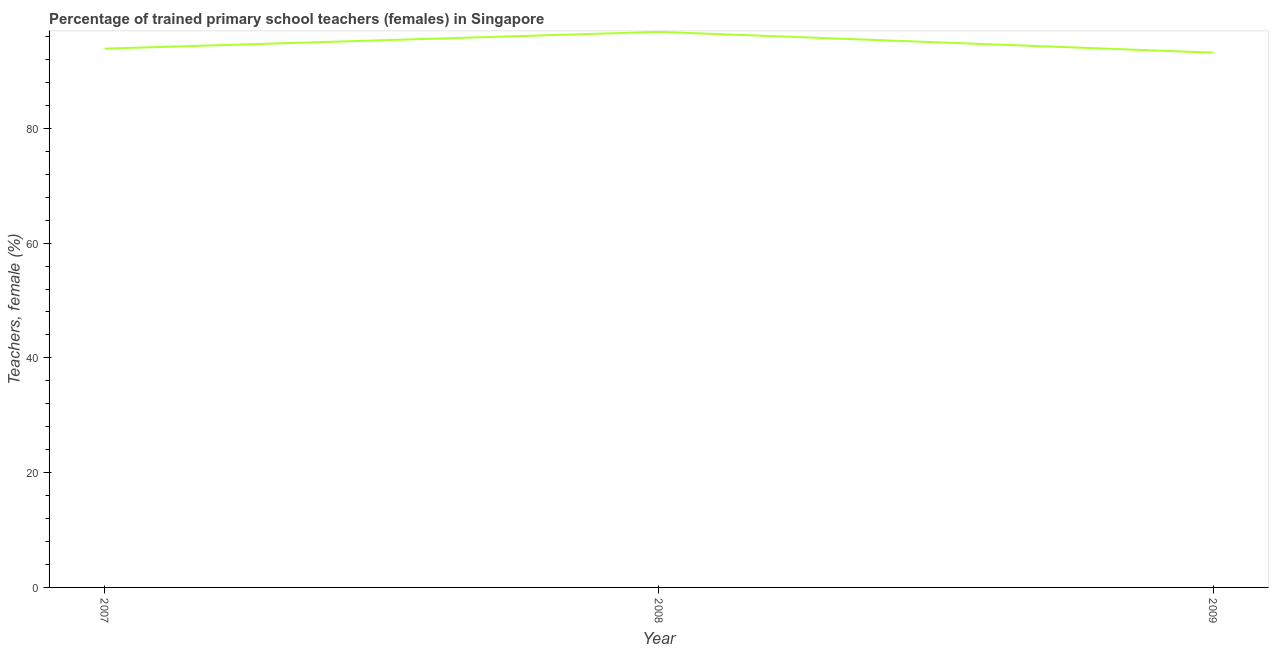What is the percentage of trained female teachers in 2008?
Make the answer very short. 96.81. Across all years, what is the maximum percentage of trained female teachers?
Your answer should be very brief. 96.81. Across all years, what is the minimum percentage of trained female teachers?
Your answer should be compact. 93.19. In which year was the percentage of trained female teachers maximum?
Provide a short and direct response. 2008. In which year was the percentage of trained female teachers minimum?
Your answer should be compact. 2009. What is the sum of the percentage of trained female teachers?
Offer a terse response. 283.88. What is the difference between the percentage of trained female teachers in 2008 and 2009?
Offer a very short reply. 3.62. What is the average percentage of trained female teachers per year?
Offer a terse response. 94.63. What is the median percentage of trained female teachers?
Provide a succinct answer. 93.88. What is the ratio of the percentage of trained female teachers in 2008 to that in 2009?
Provide a succinct answer. 1.04. Is the percentage of trained female teachers in 2007 less than that in 2009?
Give a very brief answer. No. Is the difference between the percentage of trained female teachers in 2007 and 2009 greater than the difference between any two years?
Your answer should be compact. No. What is the difference between the highest and the second highest percentage of trained female teachers?
Make the answer very short. 2.93. What is the difference between the highest and the lowest percentage of trained female teachers?
Offer a very short reply. 3.62. In how many years, is the percentage of trained female teachers greater than the average percentage of trained female teachers taken over all years?
Your response must be concise. 1. Does the percentage of trained female teachers monotonically increase over the years?
Offer a terse response. No. How many years are there in the graph?
Give a very brief answer. 3. Are the values on the major ticks of Y-axis written in scientific E-notation?
Your answer should be very brief. No. Does the graph contain any zero values?
Your answer should be very brief. No. Does the graph contain grids?
Your answer should be very brief. No. What is the title of the graph?
Provide a short and direct response. Percentage of trained primary school teachers (females) in Singapore. What is the label or title of the Y-axis?
Your response must be concise. Teachers, female (%). What is the Teachers, female (%) of 2007?
Keep it short and to the point. 93.88. What is the Teachers, female (%) of 2008?
Keep it short and to the point. 96.81. What is the Teachers, female (%) in 2009?
Make the answer very short. 93.19. What is the difference between the Teachers, female (%) in 2007 and 2008?
Offer a very short reply. -2.93. What is the difference between the Teachers, female (%) in 2007 and 2009?
Offer a very short reply. 0.7. What is the difference between the Teachers, female (%) in 2008 and 2009?
Provide a succinct answer. 3.62. What is the ratio of the Teachers, female (%) in 2007 to that in 2009?
Your answer should be very brief. 1.01. What is the ratio of the Teachers, female (%) in 2008 to that in 2009?
Provide a short and direct response. 1.04. 